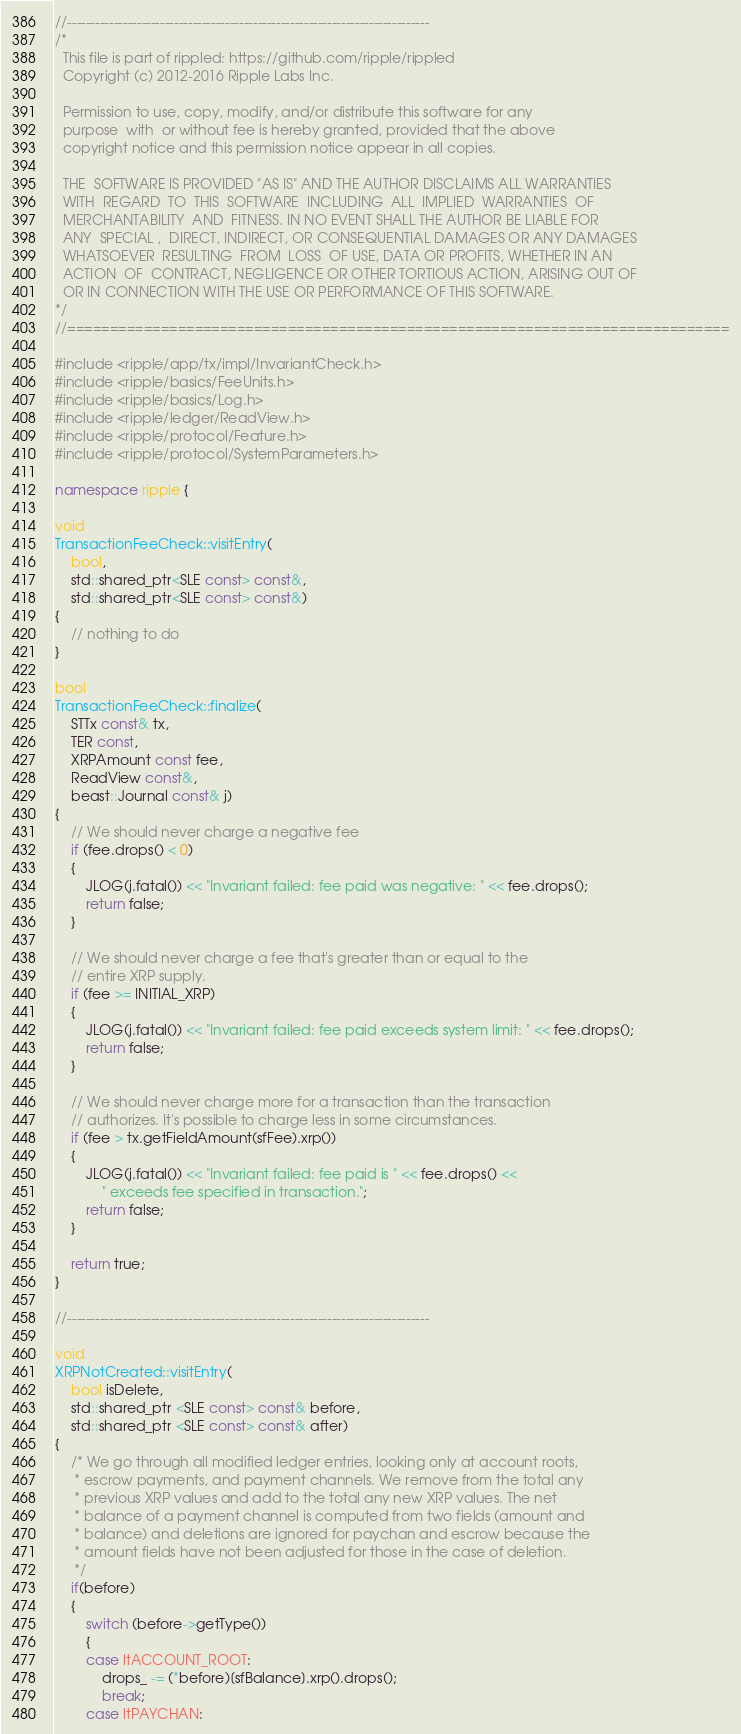<code> <loc_0><loc_0><loc_500><loc_500><_C++_>//------------------------------------------------------------------------------
/*
  This file is part of rippled: https://github.com/ripple/rippled
  Copyright (c) 2012-2016 Ripple Labs Inc.

  Permission to use, copy, modify, and/or distribute this software for any
  purpose  with  or without fee is hereby granted, provided that the above
  copyright notice and this permission notice appear in all copies.

  THE  SOFTWARE IS PROVIDED "AS IS" AND THE AUTHOR DISCLAIMS ALL WARRANTIES
  WITH  REGARD  TO  THIS  SOFTWARE  INCLUDING  ALL  IMPLIED  WARRANTIES  OF
  MERCHANTABILITY  AND  FITNESS. IN NO EVENT SHALL THE AUTHOR BE LIABLE FOR
  ANY  SPECIAL ,  DIRECT, INDIRECT, OR CONSEQUENTIAL DAMAGES OR ANY DAMAGES
  WHATSOEVER  RESULTING  FROM  LOSS  OF USE, DATA OR PROFITS, WHETHER IN AN
  ACTION  OF  CONTRACT, NEGLIGENCE OR OTHER TORTIOUS ACTION, ARISING OUT OF
  OR IN CONNECTION WITH THE USE OR PERFORMANCE OF THIS SOFTWARE.
*/
//==============================================================================

#include <ripple/app/tx/impl/InvariantCheck.h>
#include <ripple/basics/FeeUnits.h>
#include <ripple/basics/Log.h>
#include <ripple/ledger/ReadView.h>
#include <ripple/protocol/Feature.h>
#include <ripple/protocol/SystemParameters.h>

namespace ripple {

void
TransactionFeeCheck::visitEntry(
    bool,
    std::shared_ptr<SLE const> const&,
    std::shared_ptr<SLE const> const&)
{
    // nothing to do
}

bool
TransactionFeeCheck::finalize(
    STTx const& tx,
    TER const,
    XRPAmount const fee,
    ReadView const&,
    beast::Journal const& j)
{
    // We should never charge a negative fee
    if (fee.drops() < 0)
    {
        JLOG(j.fatal()) << "Invariant failed: fee paid was negative: " << fee.drops();
        return false;
    }

    // We should never charge a fee that's greater than or equal to the
    // entire XRP supply.
    if (fee >= INITIAL_XRP)
    {
        JLOG(j.fatal()) << "Invariant failed: fee paid exceeds system limit: " << fee.drops();
        return false;
    }

    // We should never charge more for a transaction than the transaction
    // authorizes. It's possible to charge less in some circumstances.
    if (fee > tx.getFieldAmount(sfFee).xrp())
    {
        JLOG(j.fatal()) << "Invariant failed: fee paid is " << fee.drops() <<
            " exceeds fee specified in transaction.";
        return false;
    }

    return true;
}

//------------------------------------------------------------------------------

void
XRPNotCreated::visitEntry(
    bool isDelete,
    std::shared_ptr <SLE const> const& before,
    std::shared_ptr <SLE const> const& after)
{
    /* We go through all modified ledger entries, looking only at account roots,
     * escrow payments, and payment channels. We remove from the total any
     * previous XRP values and add to the total any new XRP values. The net
     * balance of a payment channel is computed from two fields (amount and
     * balance) and deletions are ignored for paychan and escrow because the
     * amount fields have not been adjusted for those in the case of deletion.
     */
    if(before)
    {
        switch (before->getType())
        {
        case ltACCOUNT_ROOT:
            drops_ -= (*before)[sfBalance].xrp().drops();
            break;
        case ltPAYCHAN:</code> 